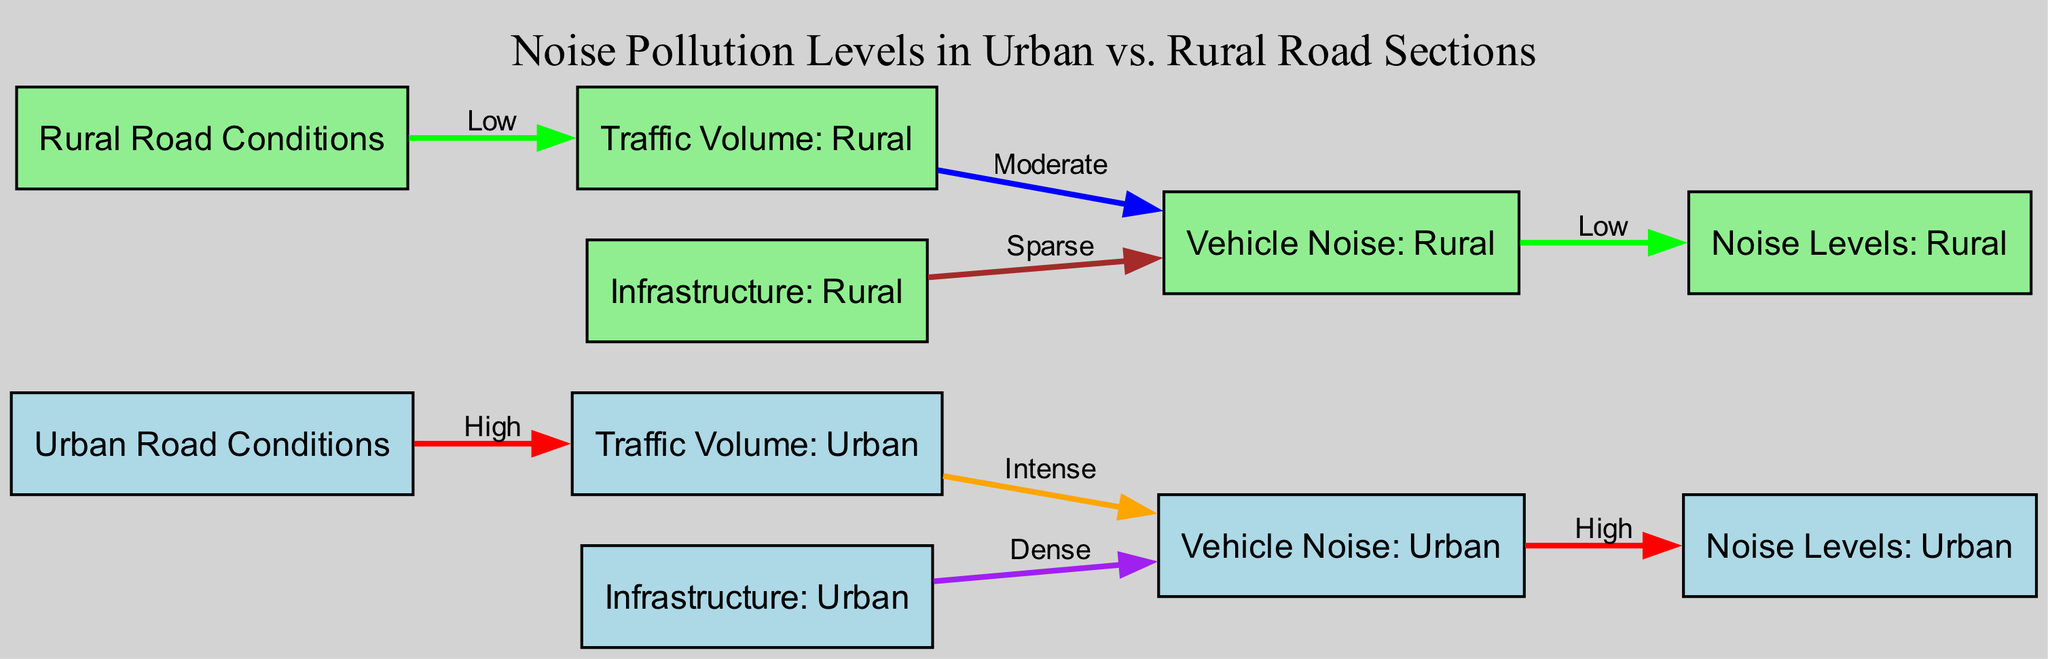What is the vehicle noise level in urban areas? The diagram indicates that vehicle noise levels in urban areas are classified as "High." This information can be found directly in the relationship stemming from the "Vehicle Noise: Urban" node to the "Noise Levels: Urban" node.
Answer: High What is the traffic volume on rural roads? According to the diagram, the traffic volume on rural roads is classified as "Low." This is indicated through the edge connecting the "Rural Road Conditions" node to the "Traffic Volume: Rural" node.
Answer: Low How do urban and rural vehicle noise levels compare? The diagram shows that urban vehicle noise is categorized as "High," while rural vehicle noise is categorized as "Low." To find this, you compare the edges leading from the "Vehicle Noise: Urban" and "Vehicle Noise: Rural" nodes to their respective noise levels.
Answer: High vs. Low What is the relationship between traffic volume and vehicle noise in urban settings? In urban settings, the diagram states that traffic volume is classified as "High," leading to vehicle noise categorized as "Intense." This relationship is represented by the edges from "Traffic Volume: Urban" to "Vehicle Noise: Urban."
Answer: Intense How does infrastructure density affect noise levels in urban versus rural areas? The diagram shows that urban infrastructure is categorized as "Dense," which leads to high vehicle noise ("High") and noise levels ("High"). In contrast, rural infrastructure is "Sparse" and leads to moderate vehicle noise ("Moderate") and low noise levels ("Low"). Thus, there is a direct correlation indicating higher density leads to higher noise levels in urban areas compared to rural.
Answer: Higher density leads to higher noise What type of noise pollution is indicated for rural road conditions? The diagram indicates that rural road conditions lead to "Low" noise levels. This is derived from the edge connecting "Vehicle Noise: Rural" to "Noise Levels: Rural."
Answer: Low Which area experiences more intense vehicle noise according to the diagram? Based on the diagram, urban areas experience more intense vehicle noise than rural areas. This can be seen by looking at the classifications for vehicle noise in both urban and rural settings, where urban is "Intense" and rural is "Moderate."
Answer: Urban What are the possible edge colors representing low traffic volume in the diagram? In the diagram, "Low" traffic volumes are represented by the color green. This color is specifically assigned to the edge linking "Rural Road Conditions" to "Traffic Volume: Rural."
Answer: Green What is indicated by the edge color between infrastructure and vehicle noise in urban areas? The edge color linking "Infrastructure: Urban" to "Vehicle Noise: Urban" is purple, which signifies "Dense." This shows the relationship that urban infrastructure density affects high vehicle noise levels.
Answer: Purple 